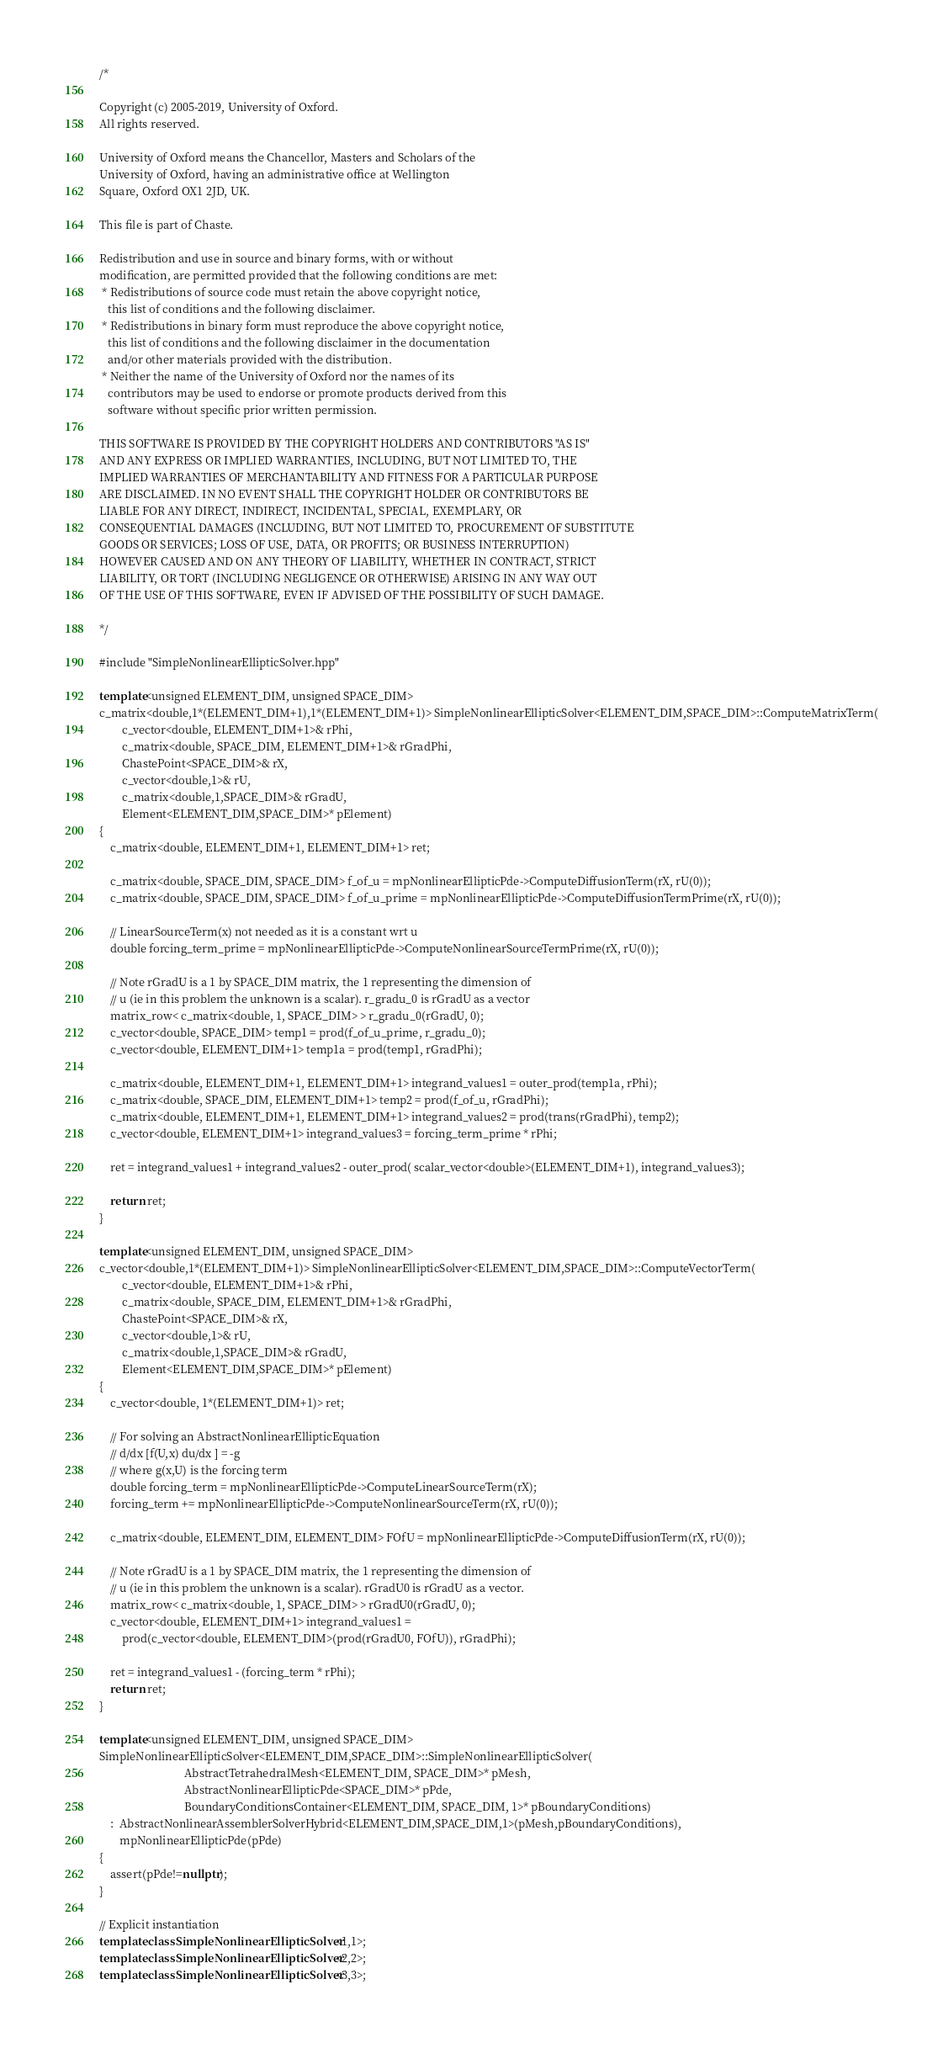<code> <loc_0><loc_0><loc_500><loc_500><_C++_>/*

Copyright (c) 2005-2019, University of Oxford.
All rights reserved.

University of Oxford means the Chancellor, Masters and Scholars of the
University of Oxford, having an administrative office at Wellington
Square, Oxford OX1 2JD, UK.

This file is part of Chaste.

Redistribution and use in source and binary forms, with or without
modification, are permitted provided that the following conditions are met:
 * Redistributions of source code must retain the above copyright notice,
   this list of conditions and the following disclaimer.
 * Redistributions in binary form must reproduce the above copyright notice,
   this list of conditions and the following disclaimer in the documentation
   and/or other materials provided with the distribution.
 * Neither the name of the University of Oxford nor the names of its
   contributors may be used to endorse or promote products derived from this
   software without specific prior written permission.

THIS SOFTWARE IS PROVIDED BY THE COPYRIGHT HOLDERS AND CONTRIBUTORS "AS IS"
AND ANY EXPRESS OR IMPLIED WARRANTIES, INCLUDING, BUT NOT LIMITED TO, THE
IMPLIED WARRANTIES OF MERCHANTABILITY AND FITNESS FOR A PARTICULAR PURPOSE
ARE DISCLAIMED. IN NO EVENT SHALL THE COPYRIGHT HOLDER OR CONTRIBUTORS BE
LIABLE FOR ANY DIRECT, INDIRECT, INCIDENTAL, SPECIAL, EXEMPLARY, OR
CONSEQUENTIAL DAMAGES (INCLUDING, BUT NOT LIMITED TO, PROCUREMENT OF SUBSTITUTE
GOODS OR SERVICES; LOSS OF USE, DATA, OR PROFITS; OR BUSINESS INTERRUPTION)
HOWEVER CAUSED AND ON ANY THEORY OF LIABILITY, WHETHER IN CONTRACT, STRICT
LIABILITY, OR TORT (INCLUDING NEGLIGENCE OR OTHERWISE) ARISING IN ANY WAY OUT
OF THE USE OF THIS SOFTWARE, EVEN IF ADVISED OF THE POSSIBILITY OF SUCH DAMAGE.

*/

#include "SimpleNonlinearEllipticSolver.hpp"

template<unsigned ELEMENT_DIM, unsigned SPACE_DIM>
c_matrix<double,1*(ELEMENT_DIM+1),1*(ELEMENT_DIM+1)> SimpleNonlinearEllipticSolver<ELEMENT_DIM,SPACE_DIM>::ComputeMatrixTerm(
        c_vector<double, ELEMENT_DIM+1>& rPhi,
        c_matrix<double, SPACE_DIM, ELEMENT_DIM+1>& rGradPhi,
        ChastePoint<SPACE_DIM>& rX,
        c_vector<double,1>& rU,
        c_matrix<double,1,SPACE_DIM>& rGradU,
        Element<ELEMENT_DIM,SPACE_DIM>* pElement)
{
    c_matrix<double, ELEMENT_DIM+1, ELEMENT_DIM+1> ret;

    c_matrix<double, SPACE_DIM, SPACE_DIM> f_of_u = mpNonlinearEllipticPde->ComputeDiffusionTerm(rX, rU(0));
    c_matrix<double, SPACE_DIM, SPACE_DIM> f_of_u_prime = mpNonlinearEllipticPde->ComputeDiffusionTermPrime(rX, rU(0));

    // LinearSourceTerm(x) not needed as it is a constant wrt u
    double forcing_term_prime = mpNonlinearEllipticPde->ComputeNonlinearSourceTermPrime(rX, rU(0));

    // Note rGradU is a 1 by SPACE_DIM matrix, the 1 representing the dimension of
    // u (ie in this problem the unknown is a scalar). r_gradu_0 is rGradU as a vector
    matrix_row< c_matrix<double, 1, SPACE_DIM> > r_gradu_0(rGradU, 0);
    c_vector<double, SPACE_DIM> temp1 = prod(f_of_u_prime, r_gradu_0);
    c_vector<double, ELEMENT_DIM+1> temp1a = prod(temp1, rGradPhi);

    c_matrix<double, ELEMENT_DIM+1, ELEMENT_DIM+1> integrand_values1 = outer_prod(temp1a, rPhi);
    c_matrix<double, SPACE_DIM, ELEMENT_DIM+1> temp2 = prod(f_of_u, rGradPhi);
    c_matrix<double, ELEMENT_DIM+1, ELEMENT_DIM+1> integrand_values2 = prod(trans(rGradPhi), temp2);
    c_vector<double, ELEMENT_DIM+1> integrand_values3 = forcing_term_prime * rPhi;

    ret = integrand_values1 + integrand_values2 - outer_prod( scalar_vector<double>(ELEMENT_DIM+1), integrand_values3);

    return ret;
}

template<unsigned ELEMENT_DIM, unsigned SPACE_DIM>
c_vector<double,1*(ELEMENT_DIM+1)> SimpleNonlinearEllipticSolver<ELEMENT_DIM,SPACE_DIM>::ComputeVectorTerm(
        c_vector<double, ELEMENT_DIM+1>& rPhi,
        c_matrix<double, SPACE_DIM, ELEMENT_DIM+1>& rGradPhi,
        ChastePoint<SPACE_DIM>& rX,
        c_vector<double,1>& rU,
        c_matrix<double,1,SPACE_DIM>& rGradU,
        Element<ELEMENT_DIM,SPACE_DIM>* pElement)
{
    c_vector<double, 1*(ELEMENT_DIM+1)> ret;

    // For solving an AbstractNonlinearEllipticEquation
    // d/dx [f(U,x) du/dx ] = -g
    // where g(x,U) is the forcing term
    double forcing_term = mpNonlinearEllipticPde->ComputeLinearSourceTerm(rX);
    forcing_term += mpNonlinearEllipticPde->ComputeNonlinearSourceTerm(rX, rU(0));

    c_matrix<double, ELEMENT_DIM, ELEMENT_DIM> FOfU = mpNonlinearEllipticPde->ComputeDiffusionTerm(rX, rU(0));

    // Note rGradU is a 1 by SPACE_DIM matrix, the 1 representing the dimension of
    // u (ie in this problem the unknown is a scalar). rGradU0 is rGradU as a vector.
    matrix_row< c_matrix<double, 1, SPACE_DIM> > rGradU0(rGradU, 0);
    c_vector<double, ELEMENT_DIM+1> integrand_values1 =
        prod(c_vector<double, ELEMENT_DIM>(prod(rGradU0, FOfU)), rGradPhi);

    ret = integrand_values1 - (forcing_term * rPhi);
    return ret;
}

template<unsigned ELEMENT_DIM, unsigned SPACE_DIM>
SimpleNonlinearEllipticSolver<ELEMENT_DIM,SPACE_DIM>::SimpleNonlinearEllipticSolver(
                              AbstractTetrahedralMesh<ELEMENT_DIM, SPACE_DIM>* pMesh,
                              AbstractNonlinearEllipticPde<SPACE_DIM>* pPde,
                              BoundaryConditionsContainer<ELEMENT_DIM, SPACE_DIM, 1>* pBoundaryConditions)
    :  AbstractNonlinearAssemblerSolverHybrid<ELEMENT_DIM,SPACE_DIM,1>(pMesh,pBoundaryConditions),
       mpNonlinearEllipticPde(pPde)
{
    assert(pPde!=nullptr);
}

// Explicit instantiation
template class SimpleNonlinearEllipticSolver<1,1>;
template class SimpleNonlinearEllipticSolver<2,2>;
template class SimpleNonlinearEllipticSolver<3,3>;
</code> 